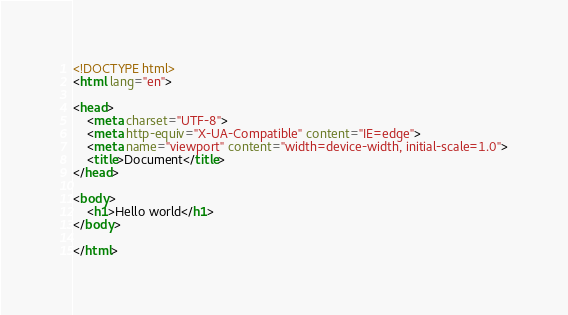<code> <loc_0><loc_0><loc_500><loc_500><_HTML_><!DOCTYPE html>
<html lang="en">

<head>
	<meta charset="UTF-8">
	<meta http-equiv="X-UA-Compatible" content="IE=edge">
	<meta name="viewport" content="width=device-width, initial-scale=1.0">
	<title>Document</title>
</head>

<body>
	<h1>Hello world</h1>
</body>

</html></code> 